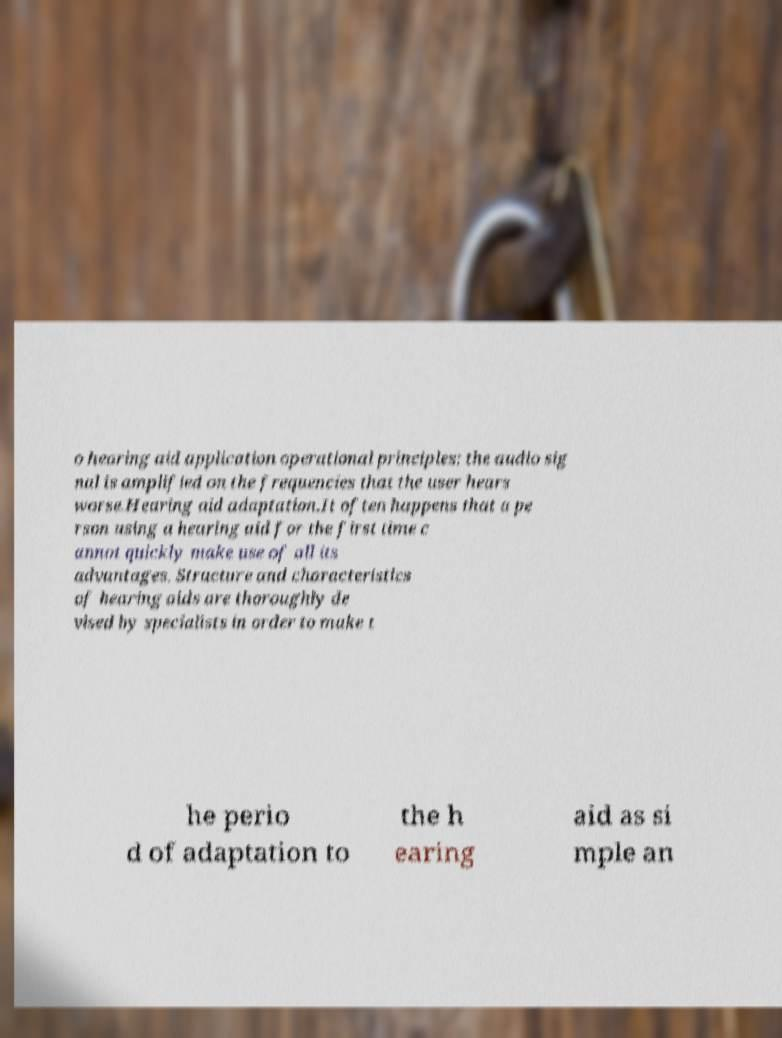For documentation purposes, I need the text within this image transcribed. Could you provide that? o hearing aid application operational principles: the audio sig nal is amplified on the frequencies that the user hears worse.Hearing aid adaptation.It often happens that a pe rson using a hearing aid for the first time c annot quickly make use of all its advantages. Structure and characteristics of hearing aids are thoroughly de vised by specialists in order to make t he perio d of adaptation to the h earing aid as si mple an 